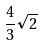<formula> <loc_0><loc_0><loc_500><loc_500>\frac { 4 } { 3 } \sqrt { 2 }</formula> 